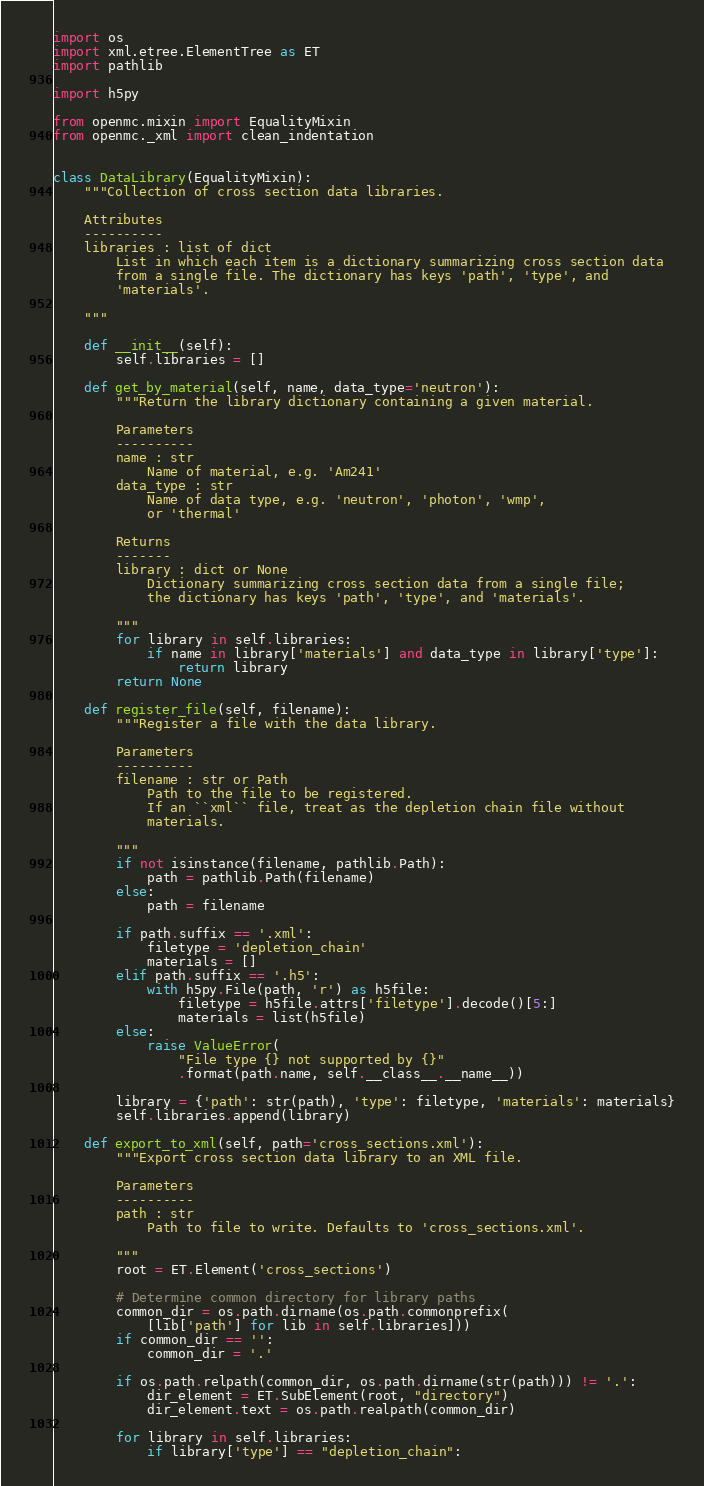Convert code to text. <code><loc_0><loc_0><loc_500><loc_500><_Python_>import os
import xml.etree.ElementTree as ET
import pathlib

import h5py

from openmc.mixin import EqualityMixin
from openmc._xml import clean_indentation


class DataLibrary(EqualityMixin):
    """Collection of cross section data libraries.

    Attributes
    ----------
    libraries : list of dict
        List in which each item is a dictionary summarizing cross section data
        from a single file. The dictionary has keys 'path', 'type', and
        'materials'.

    """

    def __init__(self):
        self.libraries = []

    def get_by_material(self, name, data_type='neutron'):
        """Return the library dictionary containing a given material.

        Parameters
        ----------
        name : str
            Name of material, e.g. 'Am241'
        data_type : str
            Name of data type, e.g. 'neutron', 'photon', 'wmp',
            or 'thermal'

        Returns
        -------
        library : dict or None
            Dictionary summarizing cross section data from a single file;
            the dictionary has keys 'path', 'type', and 'materials'.

        """
        for library in self.libraries:
            if name in library['materials'] and data_type in library['type']:
                return library
        return None

    def register_file(self, filename):
        """Register a file with the data library.

        Parameters
        ----------
        filename : str or Path
            Path to the file to be registered.
            If an ``xml`` file, treat as the depletion chain file without
            materials.

        """
        if not isinstance(filename, pathlib.Path):
            path = pathlib.Path(filename)
        else:
            path = filename

        if path.suffix == '.xml':
            filetype = 'depletion_chain'
            materials = []
        elif path.suffix == '.h5':
            with h5py.File(path, 'r') as h5file:
                filetype = h5file.attrs['filetype'].decode()[5:]
                materials = list(h5file)
        else:
            raise ValueError(
                "File type {} not supported by {}"
                .format(path.name, self.__class__.__name__))

        library = {'path': str(path), 'type': filetype, 'materials': materials}
        self.libraries.append(library)

    def export_to_xml(self, path='cross_sections.xml'):
        """Export cross section data library to an XML file.

        Parameters
        ----------
        path : str
            Path to file to write. Defaults to 'cross_sections.xml'.

        """
        root = ET.Element('cross_sections')

        # Determine common directory for library paths
        common_dir = os.path.dirname(os.path.commonprefix(
            [lib['path'] for lib in self.libraries]))
        if common_dir == '':
            common_dir = '.'

        if os.path.relpath(common_dir, os.path.dirname(str(path))) != '.':
            dir_element = ET.SubElement(root, "directory")
            dir_element.text = os.path.realpath(common_dir)

        for library in self.libraries:
            if library['type'] == "depletion_chain":</code> 